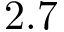<formula> <loc_0><loc_0><loc_500><loc_500>2 . 7</formula> 